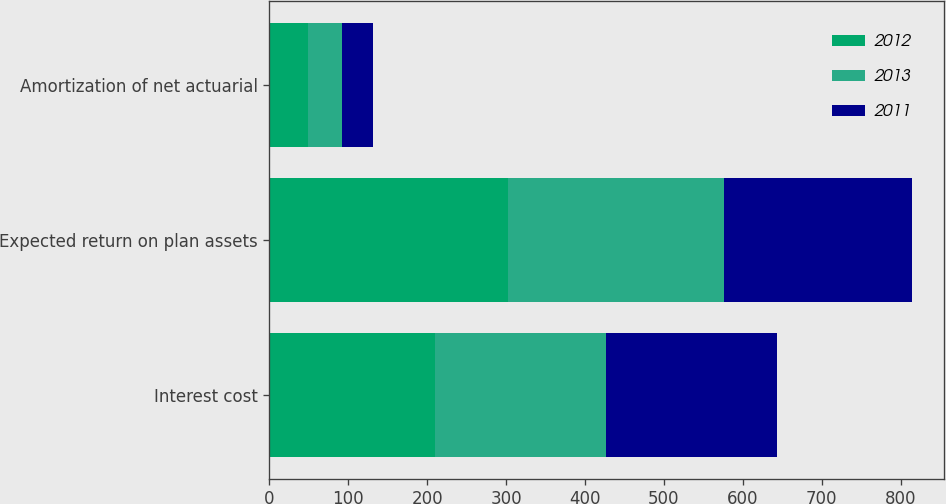<chart> <loc_0><loc_0><loc_500><loc_500><stacked_bar_chart><ecel><fcel>Interest cost<fcel>Expected return on plan assets<fcel>Amortization of net actuarial<nl><fcel>2012<fcel>210<fcel>302<fcel>49<nl><fcel>2013<fcel>217<fcel>274<fcel>43<nl><fcel>2011<fcel>216<fcel>238<fcel>39<nl></chart> 